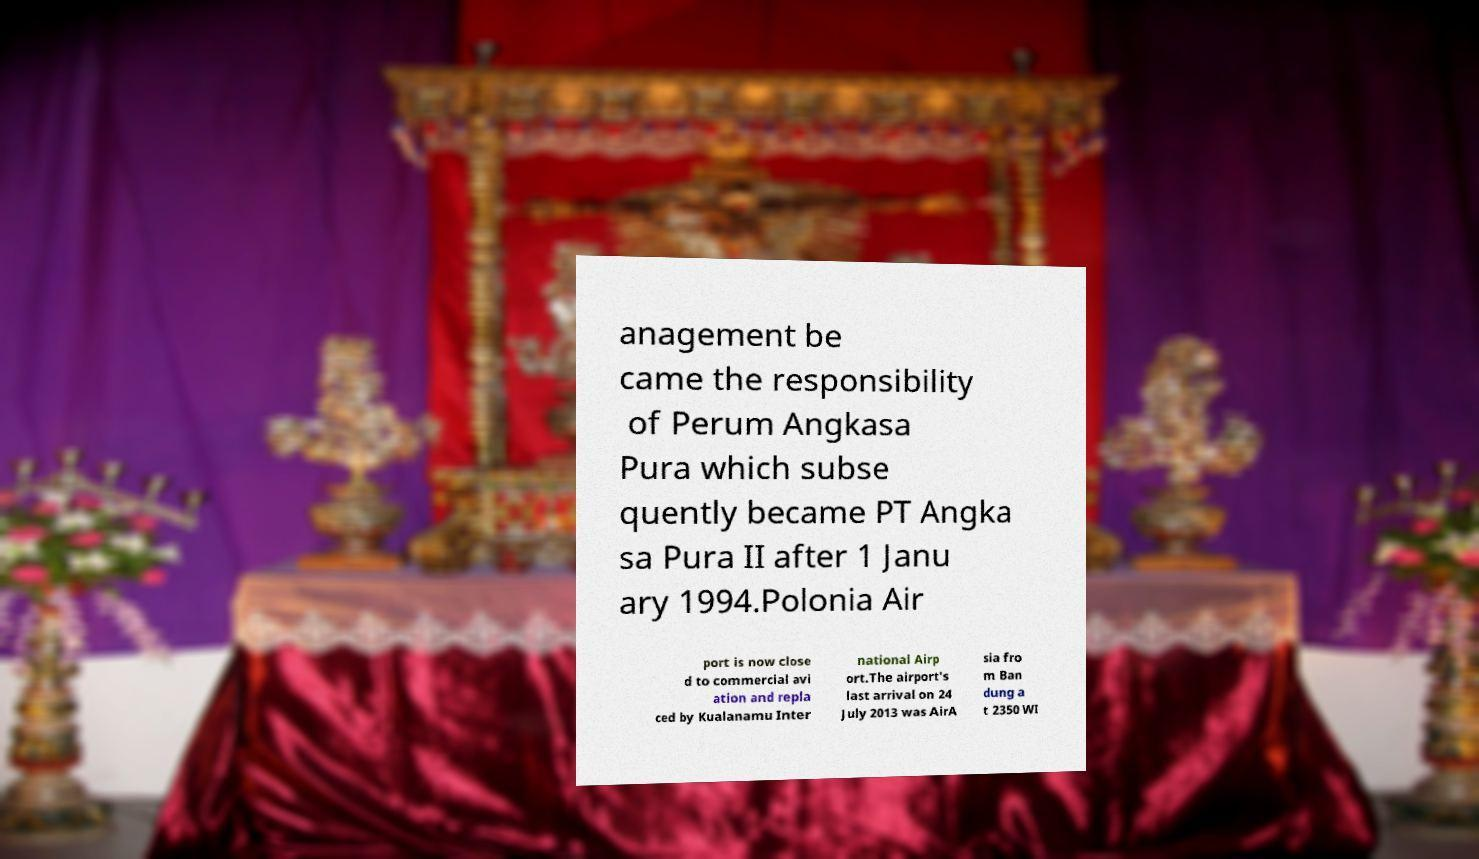Can you read and provide the text displayed in the image?This photo seems to have some interesting text. Can you extract and type it out for me? anagement be came the responsibility of Perum Angkasa Pura which subse quently became PT Angka sa Pura II after 1 Janu ary 1994.Polonia Air port is now close d to commercial avi ation and repla ced by Kualanamu Inter national Airp ort.The airport's last arrival on 24 July 2013 was AirA sia fro m Ban dung a t 2350 WI 